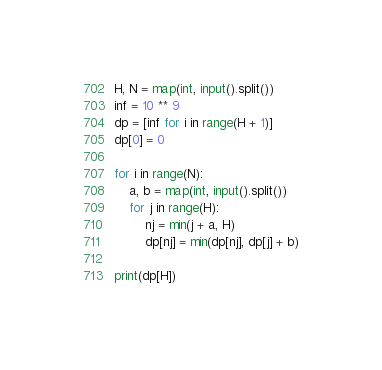<code> <loc_0><loc_0><loc_500><loc_500><_Python_>H, N = map(int, input().split())
inf = 10 ** 9
dp = [inf for i in range(H + 1)]
dp[0] = 0

for i in range(N):
    a, b = map(int, input().split())
    for j in range(H):
        nj = min(j + a, H)
        dp[nj] = min(dp[nj], dp[j] + b)

print(dp[H])
</code> 